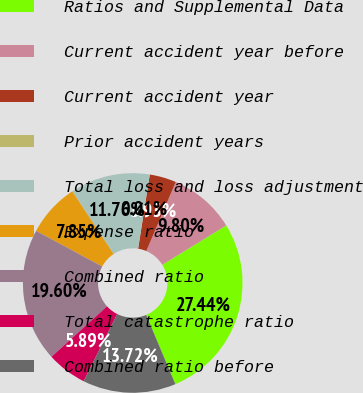<chart> <loc_0><loc_0><loc_500><loc_500><pie_chart><fcel>Ratios and Supplemental Data<fcel>Current accident year before<fcel>Current accident year<fcel>Prior accident years<fcel>Total loss and loss adjustment<fcel>Expense ratio<fcel>Combined ratio<fcel>Total catastrophe ratio<fcel>Combined ratio before<nl><fcel>27.44%<fcel>9.8%<fcel>3.93%<fcel>0.01%<fcel>11.76%<fcel>7.85%<fcel>19.6%<fcel>5.89%<fcel>13.72%<nl></chart> 